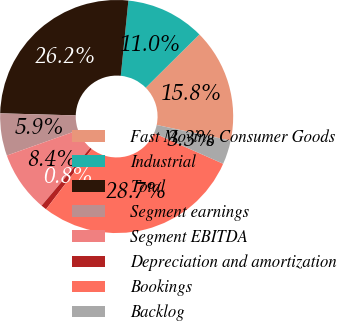Convert chart. <chart><loc_0><loc_0><loc_500><loc_500><pie_chart><fcel>Fast Moving Consumer Goods<fcel>Industrial<fcel>Total<fcel>Segment earnings<fcel>Segment EBITDA<fcel>Depreciation and amortization<fcel>Bookings<fcel>Backlog<nl><fcel>15.75%<fcel>10.96%<fcel>26.17%<fcel>5.87%<fcel>8.42%<fcel>0.79%<fcel>28.71%<fcel>3.33%<nl></chart> 